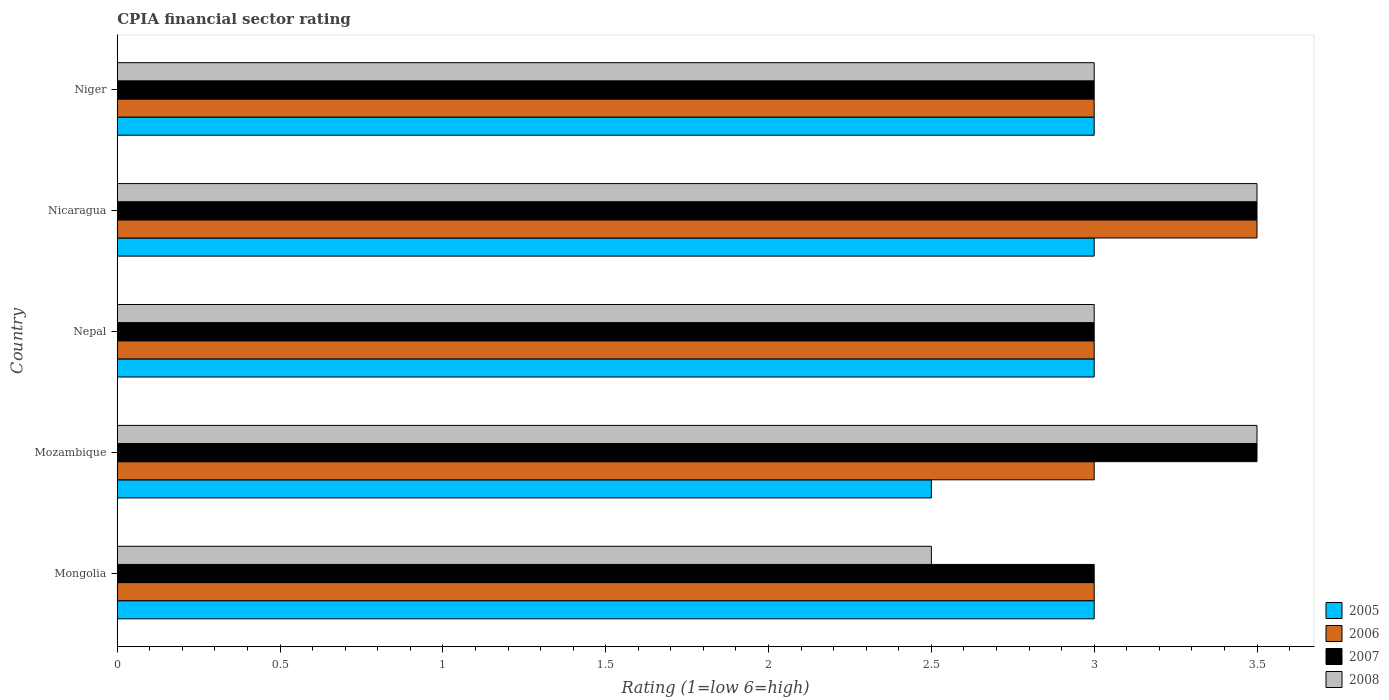Are the number of bars per tick equal to the number of legend labels?
Your answer should be very brief. Yes. Are the number of bars on each tick of the Y-axis equal?
Give a very brief answer. Yes. How many bars are there on the 1st tick from the top?
Make the answer very short. 4. How many bars are there on the 3rd tick from the bottom?
Give a very brief answer. 4. What is the label of the 3rd group of bars from the top?
Your answer should be compact. Nepal. What is the CPIA rating in 2007 in Nepal?
Make the answer very short. 3. Across all countries, what is the maximum CPIA rating in 2008?
Offer a terse response. 3.5. In which country was the CPIA rating in 2006 maximum?
Give a very brief answer. Nicaragua. In which country was the CPIA rating in 2005 minimum?
Ensure brevity in your answer.  Mozambique. What is the difference between the CPIA rating in 2007 and CPIA rating in 2005 in Mongolia?
Provide a succinct answer. 0. In how many countries, is the CPIA rating in 2008 greater than 1.9 ?
Ensure brevity in your answer.  5. What is the ratio of the CPIA rating in 2007 in Nepal to that in Nicaragua?
Your answer should be very brief. 0.86. Is the difference between the CPIA rating in 2007 in Nepal and Niger greater than the difference between the CPIA rating in 2005 in Nepal and Niger?
Offer a very short reply. No. How many bars are there?
Provide a short and direct response. 20. Are all the bars in the graph horizontal?
Give a very brief answer. Yes. What is the difference between two consecutive major ticks on the X-axis?
Make the answer very short. 0.5. What is the title of the graph?
Ensure brevity in your answer.  CPIA financial sector rating. Does "2004" appear as one of the legend labels in the graph?
Offer a very short reply. No. What is the label or title of the X-axis?
Your answer should be compact. Rating (1=low 6=high). What is the Rating (1=low 6=high) in 2005 in Mongolia?
Provide a short and direct response. 3. What is the Rating (1=low 6=high) of 2005 in Mozambique?
Your answer should be compact. 2.5. What is the Rating (1=low 6=high) of 2008 in Mozambique?
Ensure brevity in your answer.  3.5. What is the Rating (1=low 6=high) of 2005 in Nepal?
Keep it short and to the point. 3. What is the Rating (1=low 6=high) of 2006 in Nepal?
Offer a terse response. 3. What is the Rating (1=low 6=high) in 2007 in Nepal?
Offer a terse response. 3. What is the Rating (1=low 6=high) in 2005 in Nicaragua?
Offer a terse response. 3. What is the Rating (1=low 6=high) of 2008 in Nicaragua?
Your answer should be compact. 3.5. What is the Rating (1=low 6=high) in 2006 in Niger?
Keep it short and to the point. 3. Across all countries, what is the maximum Rating (1=low 6=high) of 2006?
Your answer should be compact. 3.5. Across all countries, what is the maximum Rating (1=low 6=high) of 2008?
Keep it short and to the point. 3.5. Across all countries, what is the minimum Rating (1=low 6=high) of 2007?
Your answer should be very brief. 3. What is the total Rating (1=low 6=high) of 2006 in the graph?
Your answer should be very brief. 15.5. What is the total Rating (1=low 6=high) of 2007 in the graph?
Give a very brief answer. 16. What is the difference between the Rating (1=low 6=high) in 2005 in Mongolia and that in Mozambique?
Your response must be concise. 0.5. What is the difference between the Rating (1=low 6=high) of 2006 in Mongolia and that in Mozambique?
Offer a very short reply. 0. What is the difference between the Rating (1=low 6=high) in 2007 in Mongolia and that in Mozambique?
Your response must be concise. -0.5. What is the difference between the Rating (1=low 6=high) in 2008 in Mongolia and that in Mozambique?
Provide a succinct answer. -1. What is the difference between the Rating (1=low 6=high) in 2006 in Mongolia and that in Nepal?
Ensure brevity in your answer.  0. What is the difference between the Rating (1=low 6=high) of 2008 in Mongolia and that in Nepal?
Provide a short and direct response. -0.5. What is the difference between the Rating (1=low 6=high) in 2007 in Mongolia and that in Nicaragua?
Ensure brevity in your answer.  -0.5. What is the difference between the Rating (1=low 6=high) in 2008 in Mongolia and that in Nicaragua?
Your answer should be very brief. -1. What is the difference between the Rating (1=low 6=high) in 2005 in Mozambique and that in Nepal?
Your answer should be compact. -0.5. What is the difference between the Rating (1=low 6=high) of 2008 in Mozambique and that in Nepal?
Your answer should be very brief. 0.5. What is the difference between the Rating (1=low 6=high) in 2008 in Mozambique and that in Nicaragua?
Your answer should be compact. 0. What is the difference between the Rating (1=low 6=high) of 2005 in Mozambique and that in Niger?
Your answer should be compact. -0.5. What is the difference between the Rating (1=low 6=high) in 2006 in Mozambique and that in Niger?
Your answer should be compact. 0. What is the difference between the Rating (1=low 6=high) in 2008 in Mozambique and that in Niger?
Your response must be concise. 0.5. What is the difference between the Rating (1=low 6=high) in 2005 in Nepal and that in Nicaragua?
Provide a short and direct response. 0. What is the difference between the Rating (1=low 6=high) in 2008 in Nepal and that in Nicaragua?
Offer a very short reply. -0.5. What is the difference between the Rating (1=low 6=high) of 2005 in Nepal and that in Niger?
Make the answer very short. 0. What is the difference between the Rating (1=low 6=high) in 2005 in Nicaragua and that in Niger?
Your response must be concise. 0. What is the difference between the Rating (1=low 6=high) of 2006 in Nicaragua and that in Niger?
Keep it short and to the point. 0.5. What is the difference between the Rating (1=low 6=high) in 2008 in Nicaragua and that in Niger?
Ensure brevity in your answer.  0.5. What is the difference between the Rating (1=low 6=high) of 2005 in Mongolia and the Rating (1=low 6=high) of 2008 in Nepal?
Offer a terse response. 0. What is the difference between the Rating (1=low 6=high) in 2006 in Mongolia and the Rating (1=low 6=high) in 2007 in Nepal?
Give a very brief answer. 0. What is the difference between the Rating (1=low 6=high) in 2006 in Mongolia and the Rating (1=low 6=high) in 2008 in Nepal?
Your response must be concise. 0. What is the difference between the Rating (1=low 6=high) in 2007 in Mongolia and the Rating (1=low 6=high) in 2008 in Nepal?
Ensure brevity in your answer.  0. What is the difference between the Rating (1=low 6=high) of 2005 in Mongolia and the Rating (1=low 6=high) of 2006 in Nicaragua?
Your answer should be very brief. -0.5. What is the difference between the Rating (1=low 6=high) in 2006 in Mongolia and the Rating (1=low 6=high) in 2008 in Nicaragua?
Your answer should be very brief. -0.5. What is the difference between the Rating (1=low 6=high) of 2007 in Mongolia and the Rating (1=low 6=high) of 2008 in Nicaragua?
Offer a very short reply. -0.5. What is the difference between the Rating (1=low 6=high) of 2005 in Mongolia and the Rating (1=low 6=high) of 2007 in Niger?
Keep it short and to the point. 0. What is the difference between the Rating (1=low 6=high) in 2007 in Mongolia and the Rating (1=low 6=high) in 2008 in Niger?
Your response must be concise. 0. What is the difference between the Rating (1=low 6=high) of 2006 in Mozambique and the Rating (1=low 6=high) of 2007 in Nepal?
Your answer should be compact. 0. What is the difference between the Rating (1=low 6=high) of 2005 in Mozambique and the Rating (1=low 6=high) of 2007 in Nicaragua?
Keep it short and to the point. -1. What is the difference between the Rating (1=low 6=high) of 2006 in Mozambique and the Rating (1=low 6=high) of 2008 in Nicaragua?
Your answer should be compact. -0.5. What is the difference between the Rating (1=low 6=high) of 2007 in Mozambique and the Rating (1=low 6=high) of 2008 in Nicaragua?
Your answer should be compact. 0. What is the difference between the Rating (1=low 6=high) in 2005 in Mozambique and the Rating (1=low 6=high) in 2006 in Niger?
Your answer should be very brief. -0.5. What is the difference between the Rating (1=low 6=high) in 2005 in Mozambique and the Rating (1=low 6=high) in 2007 in Niger?
Ensure brevity in your answer.  -0.5. What is the difference between the Rating (1=low 6=high) in 2005 in Mozambique and the Rating (1=low 6=high) in 2008 in Niger?
Make the answer very short. -0.5. What is the difference between the Rating (1=low 6=high) in 2006 in Mozambique and the Rating (1=low 6=high) in 2007 in Niger?
Give a very brief answer. 0. What is the difference between the Rating (1=low 6=high) in 2006 in Mozambique and the Rating (1=low 6=high) in 2008 in Niger?
Make the answer very short. 0. What is the difference between the Rating (1=low 6=high) of 2005 in Nepal and the Rating (1=low 6=high) of 2006 in Nicaragua?
Provide a succinct answer. -0.5. What is the difference between the Rating (1=low 6=high) of 2007 in Nepal and the Rating (1=low 6=high) of 2008 in Nicaragua?
Provide a succinct answer. -0.5. What is the difference between the Rating (1=low 6=high) in 2006 in Nepal and the Rating (1=low 6=high) in 2007 in Niger?
Your answer should be compact. 0. What is the difference between the Rating (1=low 6=high) of 2006 in Nepal and the Rating (1=low 6=high) of 2008 in Niger?
Keep it short and to the point. 0. What is the difference between the Rating (1=low 6=high) of 2005 in Nicaragua and the Rating (1=low 6=high) of 2006 in Niger?
Make the answer very short. 0. What is the difference between the Rating (1=low 6=high) in 2005 in Nicaragua and the Rating (1=low 6=high) in 2007 in Niger?
Your answer should be very brief. 0. What is the difference between the Rating (1=low 6=high) in 2006 in Nicaragua and the Rating (1=low 6=high) in 2008 in Niger?
Your response must be concise. 0.5. What is the difference between the Rating (1=low 6=high) in 2007 in Nicaragua and the Rating (1=low 6=high) in 2008 in Niger?
Provide a short and direct response. 0.5. What is the average Rating (1=low 6=high) of 2005 per country?
Give a very brief answer. 2.9. What is the average Rating (1=low 6=high) in 2006 per country?
Your response must be concise. 3.1. What is the average Rating (1=low 6=high) in 2007 per country?
Ensure brevity in your answer.  3.2. What is the difference between the Rating (1=low 6=high) of 2005 and Rating (1=low 6=high) of 2006 in Mongolia?
Give a very brief answer. 0. What is the difference between the Rating (1=low 6=high) in 2006 and Rating (1=low 6=high) in 2008 in Mongolia?
Your answer should be compact. 0.5. What is the difference between the Rating (1=low 6=high) of 2007 and Rating (1=low 6=high) of 2008 in Mongolia?
Your answer should be very brief. 0.5. What is the difference between the Rating (1=low 6=high) of 2005 and Rating (1=low 6=high) of 2006 in Mozambique?
Your answer should be compact. -0.5. What is the difference between the Rating (1=low 6=high) in 2006 and Rating (1=low 6=high) in 2007 in Mozambique?
Keep it short and to the point. -0.5. What is the difference between the Rating (1=low 6=high) of 2006 and Rating (1=low 6=high) of 2008 in Mozambique?
Give a very brief answer. -0.5. What is the difference between the Rating (1=low 6=high) in 2005 and Rating (1=low 6=high) in 2007 in Nepal?
Offer a terse response. 0. What is the difference between the Rating (1=low 6=high) of 2006 and Rating (1=low 6=high) of 2007 in Nepal?
Offer a terse response. 0. What is the difference between the Rating (1=low 6=high) of 2006 and Rating (1=low 6=high) of 2008 in Nepal?
Offer a terse response. 0. What is the difference between the Rating (1=low 6=high) of 2005 and Rating (1=low 6=high) of 2007 in Nicaragua?
Ensure brevity in your answer.  -0.5. What is the difference between the Rating (1=low 6=high) in 2005 and Rating (1=low 6=high) in 2008 in Nicaragua?
Give a very brief answer. -0.5. What is the difference between the Rating (1=low 6=high) in 2005 and Rating (1=low 6=high) in 2008 in Niger?
Give a very brief answer. 0. What is the difference between the Rating (1=low 6=high) in 2006 and Rating (1=low 6=high) in 2007 in Niger?
Keep it short and to the point. 0. What is the difference between the Rating (1=low 6=high) in 2006 and Rating (1=low 6=high) in 2008 in Niger?
Offer a terse response. 0. What is the difference between the Rating (1=low 6=high) of 2007 and Rating (1=low 6=high) of 2008 in Niger?
Provide a succinct answer. 0. What is the ratio of the Rating (1=low 6=high) of 2006 in Mongolia to that in Mozambique?
Your response must be concise. 1. What is the ratio of the Rating (1=low 6=high) of 2007 in Mongolia to that in Mozambique?
Make the answer very short. 0.86. What is the ratio of the Rating (1=low 6=high) of 2008 in Mongolia to that in Mozambique?
Offer a terse response. 0.71. What is the ratio of the Rating (1=low 6=high) of 2006 in Mongolia to that in Nepal?
Keep it short and to the point. 1. What is the ratio of the Rating (1=low 6=high) of 2008 in Mongolia to that in Nicaragua?
Provide a short and direct response. 0.71. What is the ratio of the Rating (1=low 6=high) of 2005 in Mongolia to that in Niger?
Provide a short and direct response. 1. What is the ratio of the Rating (1=low 6=high) in 2005 in Mozambique to that in Nepal?
Offer a very short reply. 0.83. What is the ratio of the Rating (1=low 6=high) of 2007 in Mozambique to that in Nepal?
Your answer should be compact. 1.17. What is the ratio of the Rating (1=low 6=high) in 2005 in Mozambique to that in Nicaragua?
Make the answer very short. 0.83. What is the ratio of the Rating (1=low 6=high) of 2006 in Mozambique to that in Nicaragua?
Provide a succinct answer. 0.86. What is the ratio of the Rating (1=low 6=high) in 2008 in Mozambique to that in Nicaragua?
Make the answer very short. 1. What is the ratio of the Rating (1=low 6=high) in 2006 in Mozambique to that in Niger?
Make the answer very short. 1. What is the ratio of the Rating (1=low 6=high) in 2007 in Mozambique to that in Niger?
Your response must be concise. 1.17. What is the ratio of the Rating (1=low 6=high) of 2008 in Nepal to that in Nicaragua?
Give a very brief answer. 0.86. What is the ratio of the Rating (1=low 6=high) in 2005 in Nepal to that in Niger?
Keep it short and to the point. 1. What is the ratio of the Rating (1=low 6=high) in 2006 in Nepal to that in Niger?
Your answer should be compact. 1. What is the ratio of the Rating (1=low 6=high) of 2008 in Nepal to that in Niger?
Provide a short and direct response. 1. What is the ratio of the Rating (1=low 6=high) in 2005 in Nicaragua to that in Niger?
Your answer should be very brief. 1. What is the ratio of the Rating (1=low 6=high) in 2006 in Nicaragua to that in Niger?
Ensure brevity in your answer.  1.17. What is the ratio of the Rating (1=low 6=high) in 2007 in Nicaragua to that in Niger?
Offer a very short reply. 1.17. What is the difference between the highest and the second highest Rating (1=low 6=high) in 2007?
Offer a terse response. 0. What is the difference between the highest and the second highest Rating (1=low 6=high) in 2008?
Provide a short and direct response. 0. What is the difference between the highest and the lowest Rating (1=low 6=high) of 2008?
Keep it short and to the point. 1. 